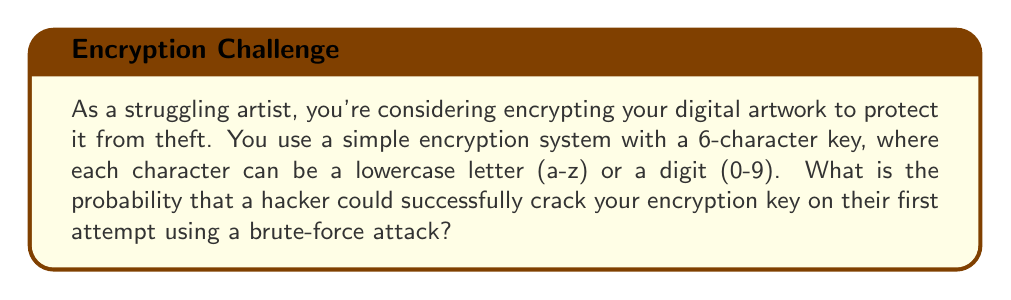Provide a solution to this math problem. Let's approach this step-by-step:

1) First, we need to determine the total number of possible characters for each position in the key:
   - 26 lowercase letters (a-z)
   - 10 digits (0-9)
   Total: 26 + 10 = 36 possible characters

2) The key is 6 characters long, and each character can be any of the 36 possibilities.

3) To calculate the total number of possible keys, we use the multiplication principle:
   $$ \text{Total keys} = 36^6 $$

4) This is because for each position, we have 36 choices, and we're making this choice 6 times independently.

5) To calculate the probability of guessing the correct key on the first try, we use the formula:
   $$ P(\text{success}) = \frac{\text{Favorable outcomes}}{\text{Total possible outcomes}} $$

6) In this case, there's only one favorable outcome (the correct key), and the total possible outcomes are $36^6$.

7) Therefore, the probability is:
   $$ P(\text{success}) = \frac{1}{36^6} = \frac{1}{2,176,782,336} \approx 4.594 \times 10^{-10} $$

This extremely low probability demonstrates why even a simple encryption system can be effective against brute-force attacks, potentially protecting your artwork from theft.
Answer: $\frac{1}{36^6}$ or approximately $4.594 \times 10^{-10}$ 